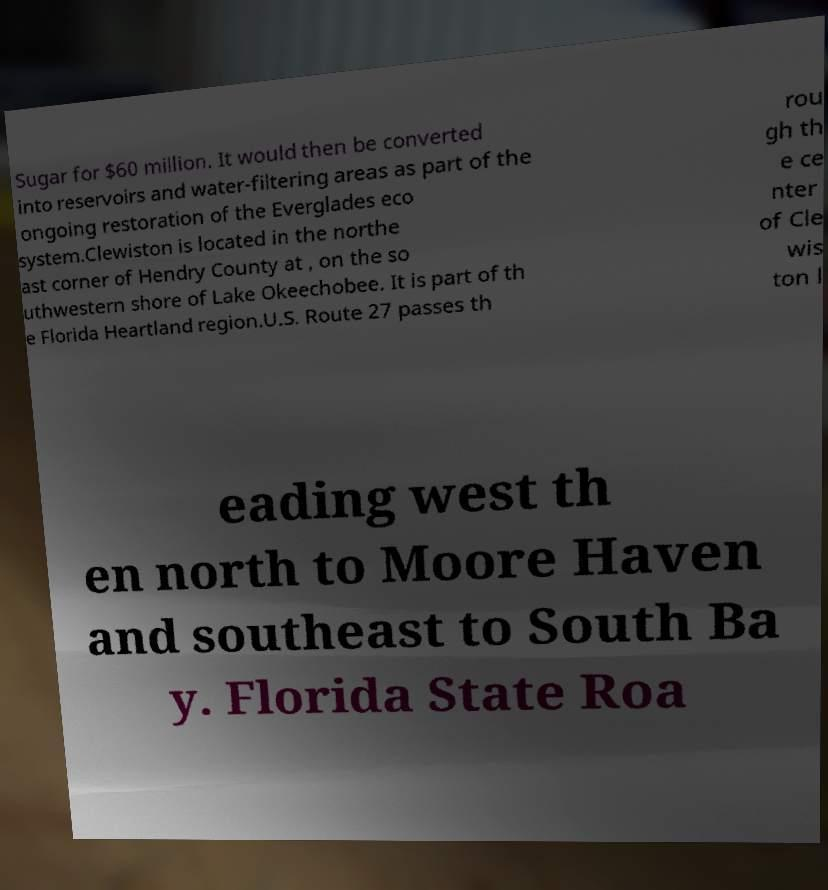Can you read and provide the text displayed in the image?This photo seems to have some interesting text. Can you extract and type it out for me? Sugar for $60 million. It would then be converted into reservoirs and water-filtering areas as part of the ongoing restoration of the Everglades eco system.Clewiston is located in the northe ast corner of Hendry County at , on the so uthwestern shore of Lake Okeechobee. It is part of th e Florida Heartland region.U.S. Route 27 passes th rou gh th e ce nter of Cle wis ton l eading west th en north to Moore Haven and southeast to South Ba y. Florida State Roa 